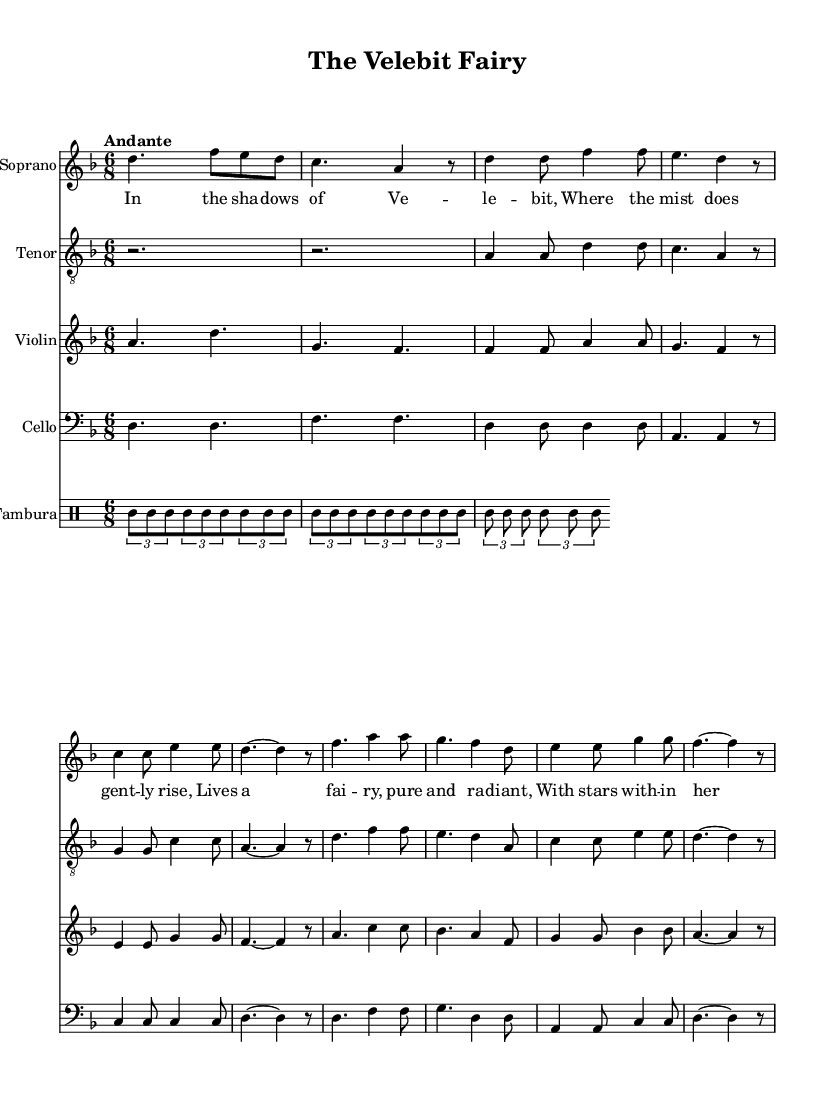What is the key signature of this music? The key signature is indicated at the beginning of the score, which shows a single flat. This corresponds to D minor, identifying that the piece is set in this key.
Answer: D minor What is the time signature of the piece? The time signature appears at the beginning of the score. It displays a 6 over 8, indicating that there are six beats in each measure with an eighth note receiving one beat.
Answer: 6/8 What is the tempo marking for this music? The tempo marking is specified above the musical staff. It states "Andante," which indicates a moderate pace in the performance of the piece.
Answer: Andante How many verses are included in the lyrics? The lyrics are divided into two sections: a verse and a chorus. Just counting the distinct lines of the verse, there are four lines present, signifying one verse in the composition.
Answer: One What is the role of the tambura in this piece? The tambura staff is designated in the score and features repetitive eighth notes in a triplet form, typical for the accompaniment role in folk-influenced music within an opera, enhancing the texture.
Answer: Accompaniment Which instrument plays the melody first? The soprano voice is featured prominently at the beginning, indicated by its placement as the first staff in the score. The opening melody is notably sung by the soprano.
Answer: Soprano What lyrical theme is portrayed in the chorus? The chorus reflects a clear thematic message, embodying reverence and a plea for blessing from the fairy which the village residents are addressing. This can be inferred directly from the lyrical content.
Answer: Blessing from the fairy 